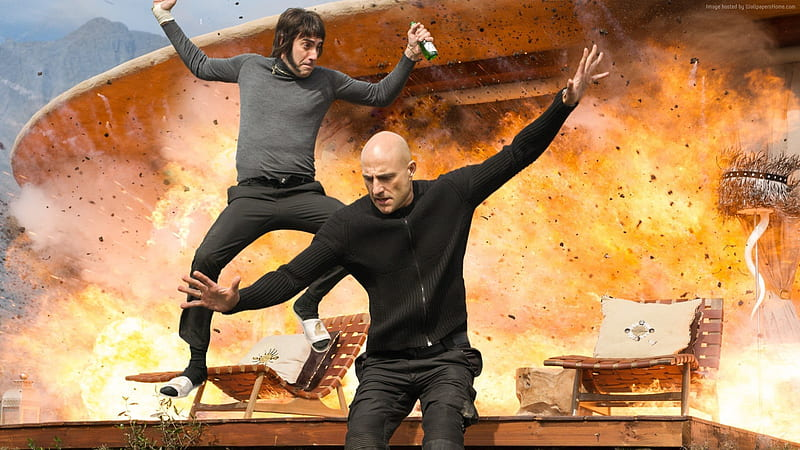Can you discuss the choice of clothing for the individuals in this image? The choice of clothing for the individuals, with dark and somewhat casual outfits, suggests practicality and a readiness for action, typical of characters involved in intense physical activities or stunts. Their outfits do not restrict movement, allowing them to perform the dynamic jumps shown. This choice also creates a visual focus against the lighter, fiery backdrop, drawing attention to their actions and expressions. 